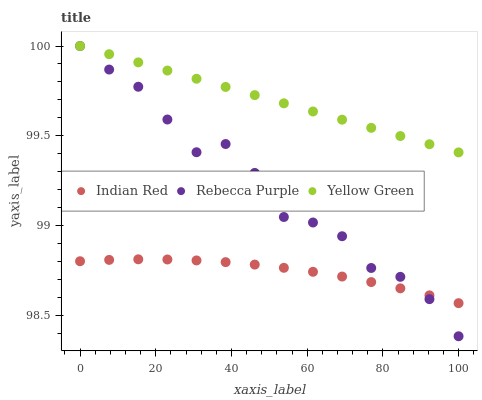Does Indian Red have the minimum area under the curve?
Answer yes or no. Yes. Does Yellow Green have the maximum area under the curve?
Answer yes or no. Yes. Does Yellow Green have the minimum area under the curve?
Answer yes or no. No. Does Indian Red have the maximum area under the curve?
Answer yes or no. No. Is Yellow Green the smoothest?
Answer yes or no. Yes. Is Rebecca Purple the roughest?
Answer yes or no. Yes. Is Indian Red the smoothest?
Answer yes or no. No. Is Indian Red the roughest?
Answer yes or no. No. Does Rebecca Purple have the lowest value?
Answer yes or no. Yes. Does Indian Red have the lowest value?
Answer yes or no. No. Does Yellow Green have the highest value?
Answer yes or no. Yes. Does Indian Red have the highest value?
Answer yes or no. No. Is Indian Red less than Yellow Green?
Answer yes or no. Yes. Is Yellow Green greater than Indian Red?
Answer yes or no. Yes. Does Rebecca Purple intersect Yellow Green?
Answer yes or no. Yes. Is Rebecca Purple less than Yellow Green?
Answer yes or no. No. Is Rebecca Purple greater than Yellow Green?
Answer yes or no. No. Does Indian Red intersect Yellow Green?
Answer yes or no. No. 